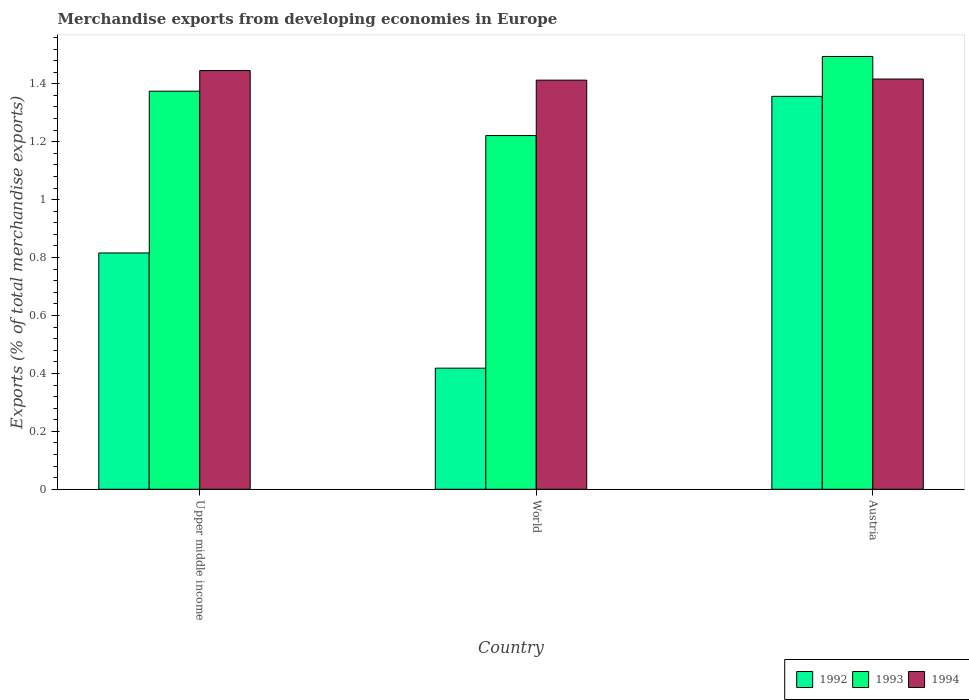How many different coloured bars are there?
Make the answer very short. 3. How many groups of bars are there?
Keep it short and to the point. 3. Are the number of bars per tick equal to the number of legend labels?
Provide a succinct answer. Yes. How many bars are there on the 3rd tick from the left?
Give a very brief answer. 3. What is the percentage of total merchandise exports in 1992 in Austria?
Ensure brevity in your answer.  1.36. Across all countries, what is the maximum percentage of total merchandise exports in 1993?
Your answer should be very brief. 1.49. Across all countries, what is the minimum percentage of total merchandise exports in 1994?
Your answer should be very brief. 1.41. In which country was the percentage of total merchandise exports in 1993 minimum?
Offer a very short reply. World. What is the total percentage of total merchandise exports in 1994 in the graph?
Your answer should be compact. 4.27. What is the difference between the percentage of total merchandise exports in 1993 in Upper middle income and that in World?
Offer a very short reply. 0.15. What is the difference between the percentage of total merchandise exports in 1992 in Upper middle income and the percentage of total merchandise exports in 1994 in Austria?
Offer a terse response. -0.6. What is the average percentage of total merchandise exports in 1994 per country?
Offer a very short reply. 1.42. What is the difference between the percentage of total merchandise exports of/in 1992 and percentage of total merchandise exports of/in 1993 in World?
Your answer should be very brief. -0.8. In how many countries, is the percentage of total merchandise exports in 1994 greater than 1.52 %?
Your response must be concise. 0. What is the ratio of the percentage of total merchandise exports in 1992 in Austria to that in Upper middle income?
Offer a terse response. 1.66. Is the percentage of total merchandise exports in 1994 in Upper middle income less than that in World?
Offer a very short reply. No. Is the difference between the percentage of total merchandise exports in 1992 in Austria and Upper middle income greater than the difference between the percentage of total merchandise exports in 1993 in Austria and Upper middle income?
Your answer should be very brief. Yes. What is the difference between the highest and the second highest percentage of total merchandise exports in 1994?
Ensure brevity in your answer.  0.03. What is the difference between the highest and the lowest percentage of total merchandise exports in 1992?
Offer a terse response. 0.94. Is the sum of the percentage of total merchandise exports in 1993 in Upper middle income and World greater than the maximum percentage of total merchandise exports in 1992 across all countries?
Ensure brevity in your answer.  Yes. What does the 3rd bar from the left in World represents?
Offer a terse response. 1994. What does the 2nd bar from the right in Upper middle income represents?
Your answer should be very brief. 1993. Is it the case that in every country, the sum of the percentage of total merchandise exports in 1993 and percentage of total merchandise exports in 1992 is greater than the percentage of total merchandise exports in 1994?
Offer a very short reply. Yes. What is the difference between two consecutive major ticks on the Y-axis?
Ensure brevity in your answer.  0.2. Are the values on the major ticks of Y-axis written in scientific E-notation?
Provide a succinct answer. No. Does the graph contain grids?
Make the answer very short. No. What is the title of the graph?
Your response must be concise. Merchandise exports from developing economies in Europe. Does "2013" appear as one of the legend labels in the graph?
Provide a succinct answer. No. What is the label or title of the Y-axis?
Offer a terse response. Exports (% of total merchandise exports). What is the Exports (% of total merchandise exports) in 1992 in Upper middle income?
Your answer should be very brief. 0.82. What is the Exports (% of total merchandise exports) of 1993 in Upper middle income?
Provide a succinct answer. 1.37. What is the Exports (% of total merchandise exports) in 1994 in Upper middle income?
Your answer should be compact. 1.45. What is the Exports (% of total merchandise exports) of 1992 in World?
Your response must be concise. 0.42. What is the Exports (% of total merchandise exports) of 1993 in World?
Provide a short and direct response. 1.22. What is the Exports (% of total merchandise exports) in 1994 in World?
Keep it short and to the point. 1.41. What is the Exports (% of total merchandise exports) of 1992 in Austria?
Ensure brevity in your answer.  1.36. What is the Exports (% of total merchandise exports) of 1993 in Austria?
Your answer should be very brief. 1.49. What is the Exports (% of total merchandise exports) of 1994 in Austria?
Make the answer very short. 1.42. Across all countries, what is the maximum Exports (% of total merchandise exports) in 1992?
Your answer should be compact. 1.36. Across all countries, what is the maximum Exports (% of total merchandise exports) of 1993?
Offer a terse response. 1.49. Across all countries, what is the maximum Exports (% of total merchandise exports) in 1994?
Provide a short and direct response. 1.45. Across all countries, what is the minimum Exports (% of total merchandise exports) in 1992?
Provide a succinct answer. 0.42. Across all countries, what is the minimum Exports (% of total merchandise exports) in 1993?
Offer a terse response. 1.22. Across all countries, what is the minimum Exports (% of total merchandise exports) of 1994?
Your answer should be compact. 1.41. What is the total Exports (% of total merchandise exports) of 1992 in the graph?
Give a very brief answer. 2.59. What is the total Exports (% of total merchandise exports) in 1993 in the graph?
Provide a succinct answer. 4.09. What is the total Exports (% of total merchandise exports) of 1994 in the graph?
Ensure brevity in your answer.  4.27. What is the difference between the Exports (% of total merchandise exports) of 1992 in Upper middle income and that in World?
Offer a terse response. 0.4. What is the difference between the Exports (% of total merchandise exports) in 1993 in Upper middle income and that in World?
Offer a terse response. 0.15. What is the difference between the Exports (% of total merchandise exports) of 1994 in Upper middle income and that in World?
Ensure brevity in your answer.  0.03. What is the difference between the Exports (% of total merchandise exports) in 1992 in Upper middle income and that in Austria?
Provide a short and direct response. -0.54. What is the difference between the Exports (% of total merchandise exports) of 1993 in Upper middle income and that in Austria?
Your response must be concise. -0.12. What is the difference between the Exports (% of total merchandise exports) in 1994 in Upper middle income and that in Austria?
Your answer should be very brief. 0.03. What is the difference between the Exports (% of total merchandise exports) in 1992 in World and that in Austria?
Your response must be concise. -0.94. What is the difference between the Exports (% of total merchandise exports) in 1993 in World and that in Austria?
Keep it short and to the point. -0.27. What is the difference between the Exports (% of total merchandise exports) of 1994 in World and that in Austria?
Your answer should be very brief. -0. What is the difference between the Exports (% of total merchandise exports) in 1992 in Upper middle income and the Exports (% of total merchandise exports) in 1993 in World?
Your response must be concise. -0.41. What is the difference between the Exports (% of total merchandise exports) of 1992 in Upper middle income and the Exports (% of total merchandise exports) of 1994 in World?
Provide a short and direct response. -0.6. What is the difference between the Exports (% of total merchandise exports) in 1993 in Upper middle income and the Exports (% of total merchandise exports) in 1994 in World?
Your answer should be compact. -0.04. What is the difference between the Exports (% of total merchandise exports) in 1992 in Upper middle income and the Exports (% of total merchandise exports) in 1993 in Austria?
Give a very brief answer. -0.68. What is the difference between the Exports (% of total merchandise exports) of 1992 in Upper middle income and the Exports (% of total merchandise exports) of 1994 in Austria?
Provide a short and direct response. -0.6. What is the difference between the Exports (% of total merchandise exports) of 1993 in Upper middle income and the Exports (% of total merchandise exports) of 1994 in Austria?
Give a very brief answer. -0.04. What is the difference between the Exports (% of total merchandise exports) in 1992 in World and the Exports (% of total merchandise exports) in 1993 in Austria?
Your answer should be compact. -1.08. What is the difference between the Exports (% of total merchandise exports) in 1992 in World and the Exports (% of total merchandise exports) in 1994 in Austria?
Your answer should be compact. -1. What is the difference between the Exports (% of total merchandise exports) of 1993 in World and the Exports (% of total merchandise exports) of 1994 in Austria?
Your answer should be compact. -0.2. What is the average Exports (% of total merchandise exports) of 1992 per country?
Make the answer very short. 0.86. What is the average Exports (% of total merchandise exports) in 1993 per country?
Your response must be concise. 1.36. What is the average Exports (% of total merchandise exports) in 1994 per country?
Ensure brevity in your answer.  1.42. What is the difference between the Exports (% of total merchandise exports) of 1992 and Exports (% of total merchandise exports) of 1993 in Upper middle income?
Your response must be concise. -0.56. What is the difference between the Exports (% of total merchandise exports) in 1992 and Exports (% of total merchandise exports) in 1994 in Upper middle income?
Offer a very short reply. -0.63. What is the difference between the Exports (% of total merchandise exports) in 1993 and Exports (% of total merchandise exports) in 1994 in Upper middle income?
Give a very brief answer. -0.07. What is the difference between the Exports (% of total merchandise exports) of 1992 and Exports (% of total merchandise exports) of 1993 in World?
Your response must be concise. -0.8. What is the difference between the Exports (% of total merchandise exports) in 1992 and Exports (% of total merchandise exports) in 1994 in World?
Provide a short and direct response. -0.99. What is the difference between the Exports (% of total merchandise exports) in 1993 and Exports (% of total merchandise exports) in 1994 in World?
Ensure brevity in your answer.  -0.19. What is the difference between the Exports (% of total merchandise exports) in 1992 and Exports (% of total merchandise exports) in 1993 in Austria?
Offer a very short reply. -0.14. What is the difference between the Exports (% of total merchandise exports) of 1992 and Exports (% of total merchandise exports) of 1994 in Austria?
Your answer should be compact. -0.06. What is the difference between the Exports (% of total merchandise exports) of 1993 and Exports (% of total merchandise exports) of 1994 in Austria?
Offer a very short reply. 0.08. What is the ratio of the Exports (% of total merchandise exports) in 1992 in Upper middle income to that in World?
Your response must be concise. 1.95. What is the ratio of the Exports (% of total merchandise exports) of 1993 in Upper middle income to that in World?
Ensure brevity in your answer.  1.13. What is the ratio of the Exports (% of total merchandise exports) in 1994 in Upper middle income to that in World?
Offer a very short reply. 1.02. What is the ratio of the Exports (% of total merchandise exports) of 1992 in Upper middle income to that in Austria?
Offer a very short reply. 0.6. What is the ratio of the Exports (% of total merchandise exports) of 1993 in Upper middle income to that in Austria?
Ensure brevity in your answer.  0.92. What is the ratio of the Exports (% of total merchandise exports) of 1994 in Upper middle income to that in Austria?
Provide a short and direct response. 1.02. What is the ratio of the Exports (% of total merchandise exports) in 1992 in World to that in Austria?
Give a very brief answer. 0.31. What is the ratio of the Exports (% of total merchandise exports) in 1993 in World to that in Austria?
Your answer should be compact. 0.82. What is the ratio of the Exports (% of total merchandise exports) of 1994 in World to that in Austria?
Offer a terse response. 1. What is the difference between the highest and the second highest Exports (% of total merchandise exports) of 1992?
Your response must be concise. 0.54. What is the difference between the highest and the second highest Exports (% of total merchandise exports) of 1993?
Provide a short and direct response. 0.12. What is the difference between the highest and the second highest Exports (% of total merchandise exports) of 1994?
Give a very brief answer. 0.03. What is the difference between the highest and the lowest Exports (% of total merchandise exports) of 1992?
Your answer should be compact. 0.94. What is the difference between the highest and the lowest Exports (% of total merchandise exports) in 1993?
Offer a very short reply. 0.27. What is the difference between the highest and the lowest Exports (% of total merchandise exports) in 1994?
Provide a succinct answer. 0.03. 